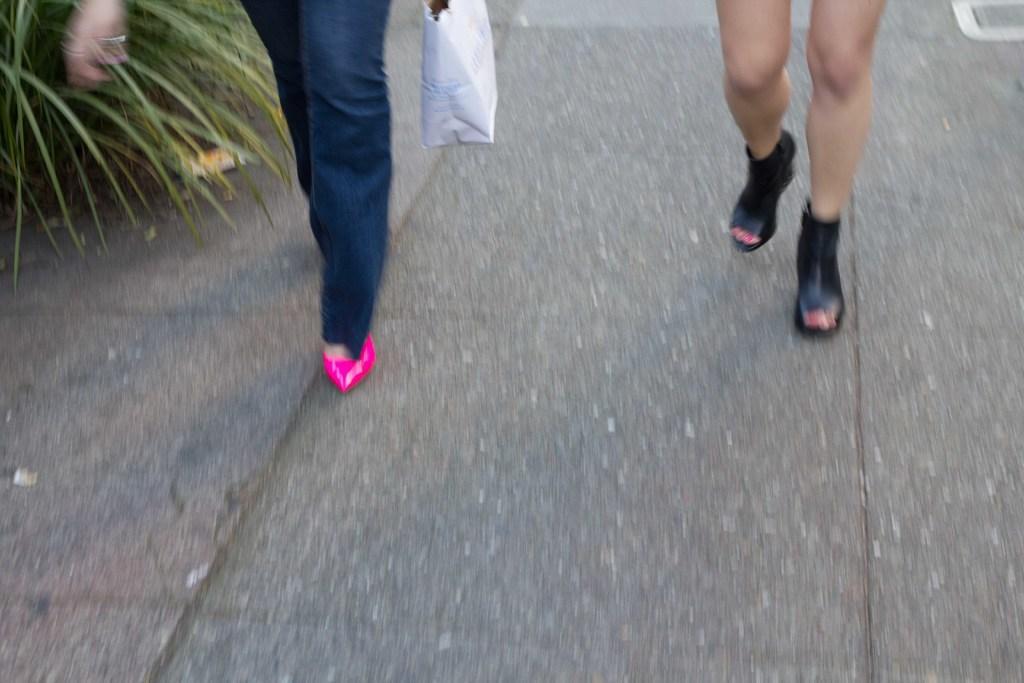In one or two sentences, can you explain what this image depicts? In this image, we can see a floor and there are two persons walking, at the left side there is a green color plant. 